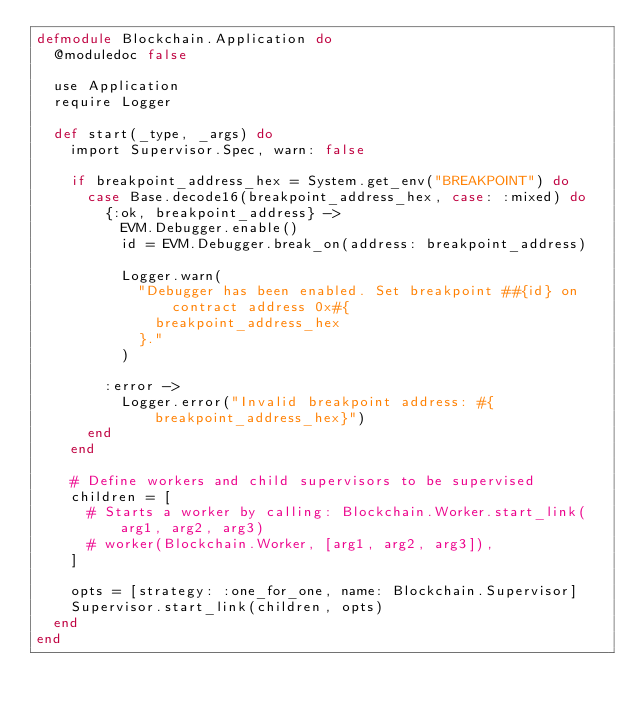Convert code to text. <code><loc_0><loc_0><loc_500><loc_500><_Elixir_>defmodule Blockchain.Application do
  @moduledoc false

  use Application
  require Logger

  def start(_type, _args) do
    import Supervisor.Spec, warn: false

    if breakpoint_address_hex = System.get_env("BREAKPOINT") do
      case Base.decode16(breakpoint_address_hex, case: :mixed) do
        {:ok, breakpoint_address} ->
          EVM.Debugger.enable()
          id = EVM.Debugger.break_on(address: breakpoint_address)

          Logger.warn(
            "Debugger has been enabled. Set breakpoint ##{id} on contract address 0x#{
              breakpoint_address_hex
            }."
          )

        :error ->
          Logger.error("Invalid breakpoint address: #{breakpoint_address_hex}")
      end
    end

    # Define workers and child supervisors to be supervised
    children = [
      # Starts a worker by calling: Blockchain.Worker.start_link(arg1, arg2, arg3)
      # worker(Blockchain.Worker, [arg1, arg2, arg3]),
    ]

    opts = [strategy: :one_for_one, name: Blockchain.Supervisor]
    Supervisor.start_link(children, opts)
  end
end
</code> 